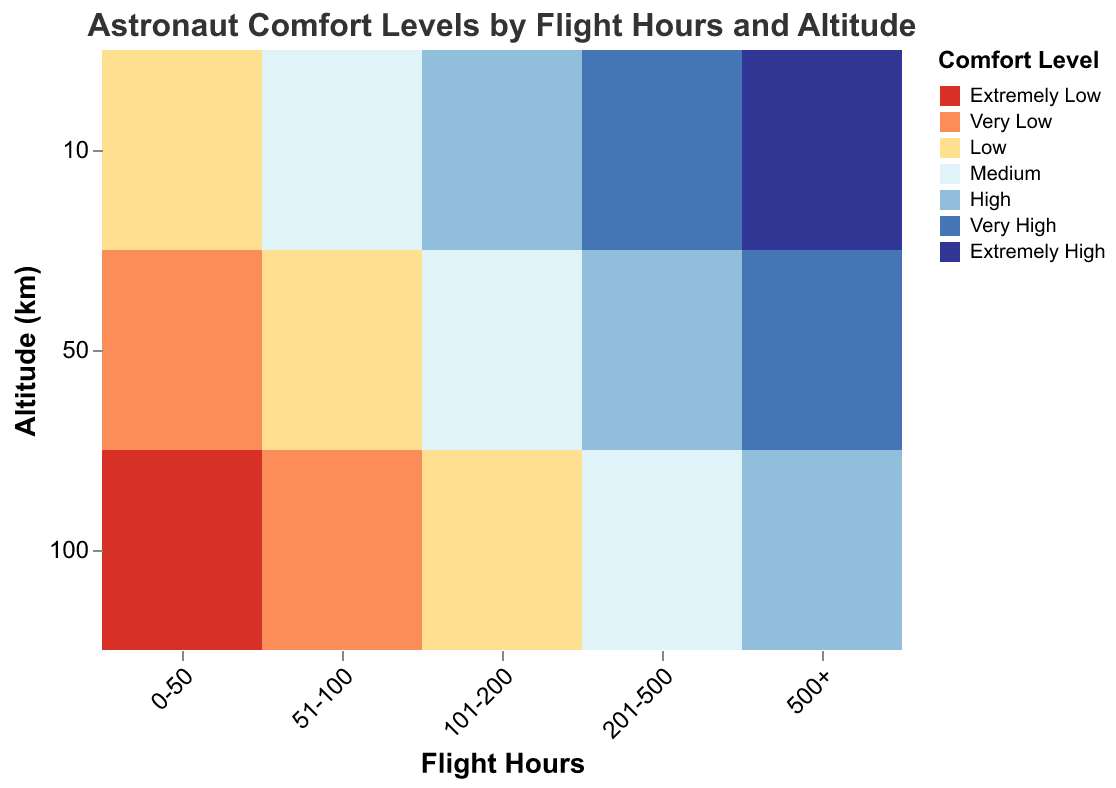What is the title of the chart? The title of the chart is typically displayed at the top and provides a summary of the chart's content. In this case, the title is "Astronaut Comfort Levels by Flight Hours and Altitude"
Answer: Astronaut Comfort Levels by Flight Hours and Altitude What are the categories on the x-axis? The x-axis categories represent the ranges of flight hours. From left to right, these categories are "0-50", "51-100", "101-200", "201-500", and "500+"
Answer: 0-50, 51-100, 101-200, 201-500, 500+ Which comfort level appears most frequently at 10 km altitude? By examining the different colors representing comfort levels at 10 km altitude across all flight hours, the most frequently occurring color can be identified. "Extremely High" appears most often
Answer: Extremely High How does the comfort level change with increased altitude for flight hours between 51-100? At 10 km, the comfort level is Medium; at 50 km, it drops to Low; and at 100 km, it further drops to Very Low, indicating a decreasing comfort level with increased altitude
Answer: Decreases Which altitude shows a high comfort level for flight hours ranging from 101-200? The High comfort level, represented by a specific color, is located at 10 km altitude for the flight hours 101-200. This means that out of the altitudes considered, only 10 km shows a high comfort level
Answer: 10 km What flight hour range has the lowest comfort level at 100 km? By checking the comfort levels at 100 km altitude across all flight hour ranges, "0-50" has the lowest comfort level, which is Extremely Low
Answer: 0-50 Which flight hour range maintains high or very high comfort levels at 50 km altitude? Observing the color codes for comfort levels at 50 km altitude, the ranges "201-500" and "500+" maintain High or Very High comfort levels respectively
Answer: 201-500, 500+ Compare the comfort levels at 10 km altitude for the highest and lowest flight hour categories. At 10 km altitude, the flight hour category "0-50" has a Low comfort level, while "500+" has an Extremely High comfort level. This indicates a significant increase in comfort with more flight hours
Answer: Significant increase How many different comfort levels are represented in the chart? The legend of the chart shows different color codes for each comfort level. There are 7 unique comfort levels represented: Extremely Low, Very Low, Low, Medium, High, Very High, and Extremely High
Answer: 7 Is there any correlation between the amount of flight hours and comfort level at higher altitudes? Higher flight hours tend to correlate with higher comfort levels, especially noticeable at 100 km altitude where the comfort level ranges from Extremely Low for "0-50" hours to High for "500+" hours
Answer: Yes, higher flight hours correlate with higher comfort levels at higher altitudes 